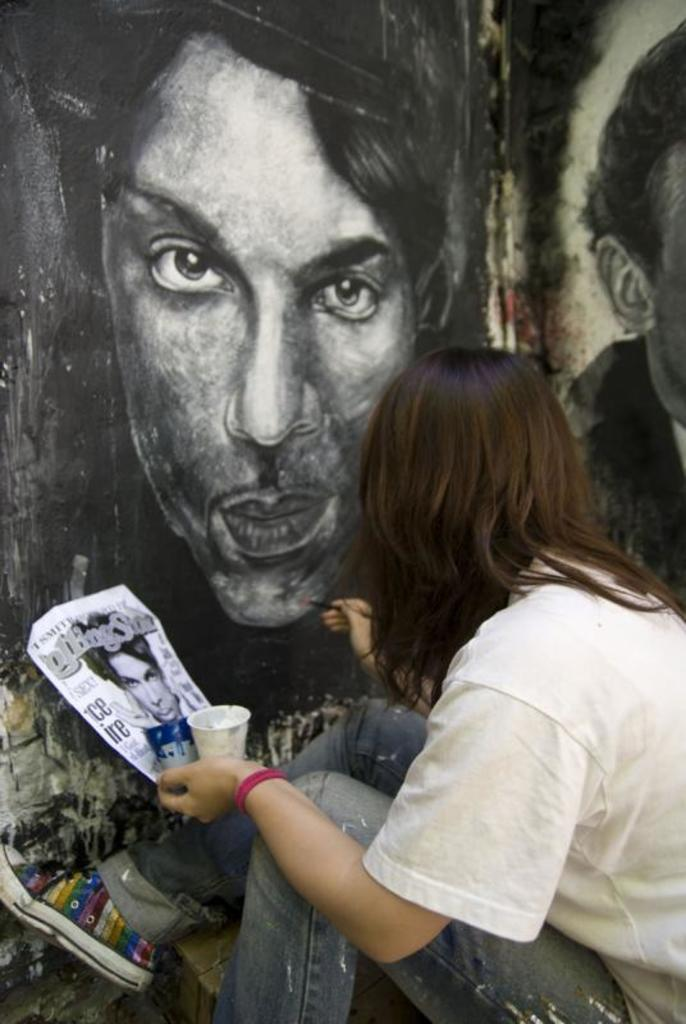What is the person in the image holding in their hands? The person is holding cups, a paper, and a paint brush in the image. What might the person be doing with the paper? The person might be using the paper to write or draw on. What can be seen on the wall in the background of the image? There is a painting on the wall in the background of the image. What type of nose can be seen on the sister in the image? There is no sister present in the image, and therefore no nose to describe. 